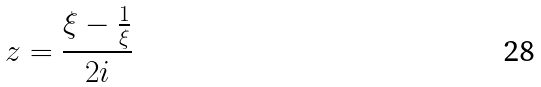<formula> <loc_0><loc_0><loc_500><loc_500>z = \frac { \xi - \frac { 1 } { \xi } } { 2 i }</formula> 